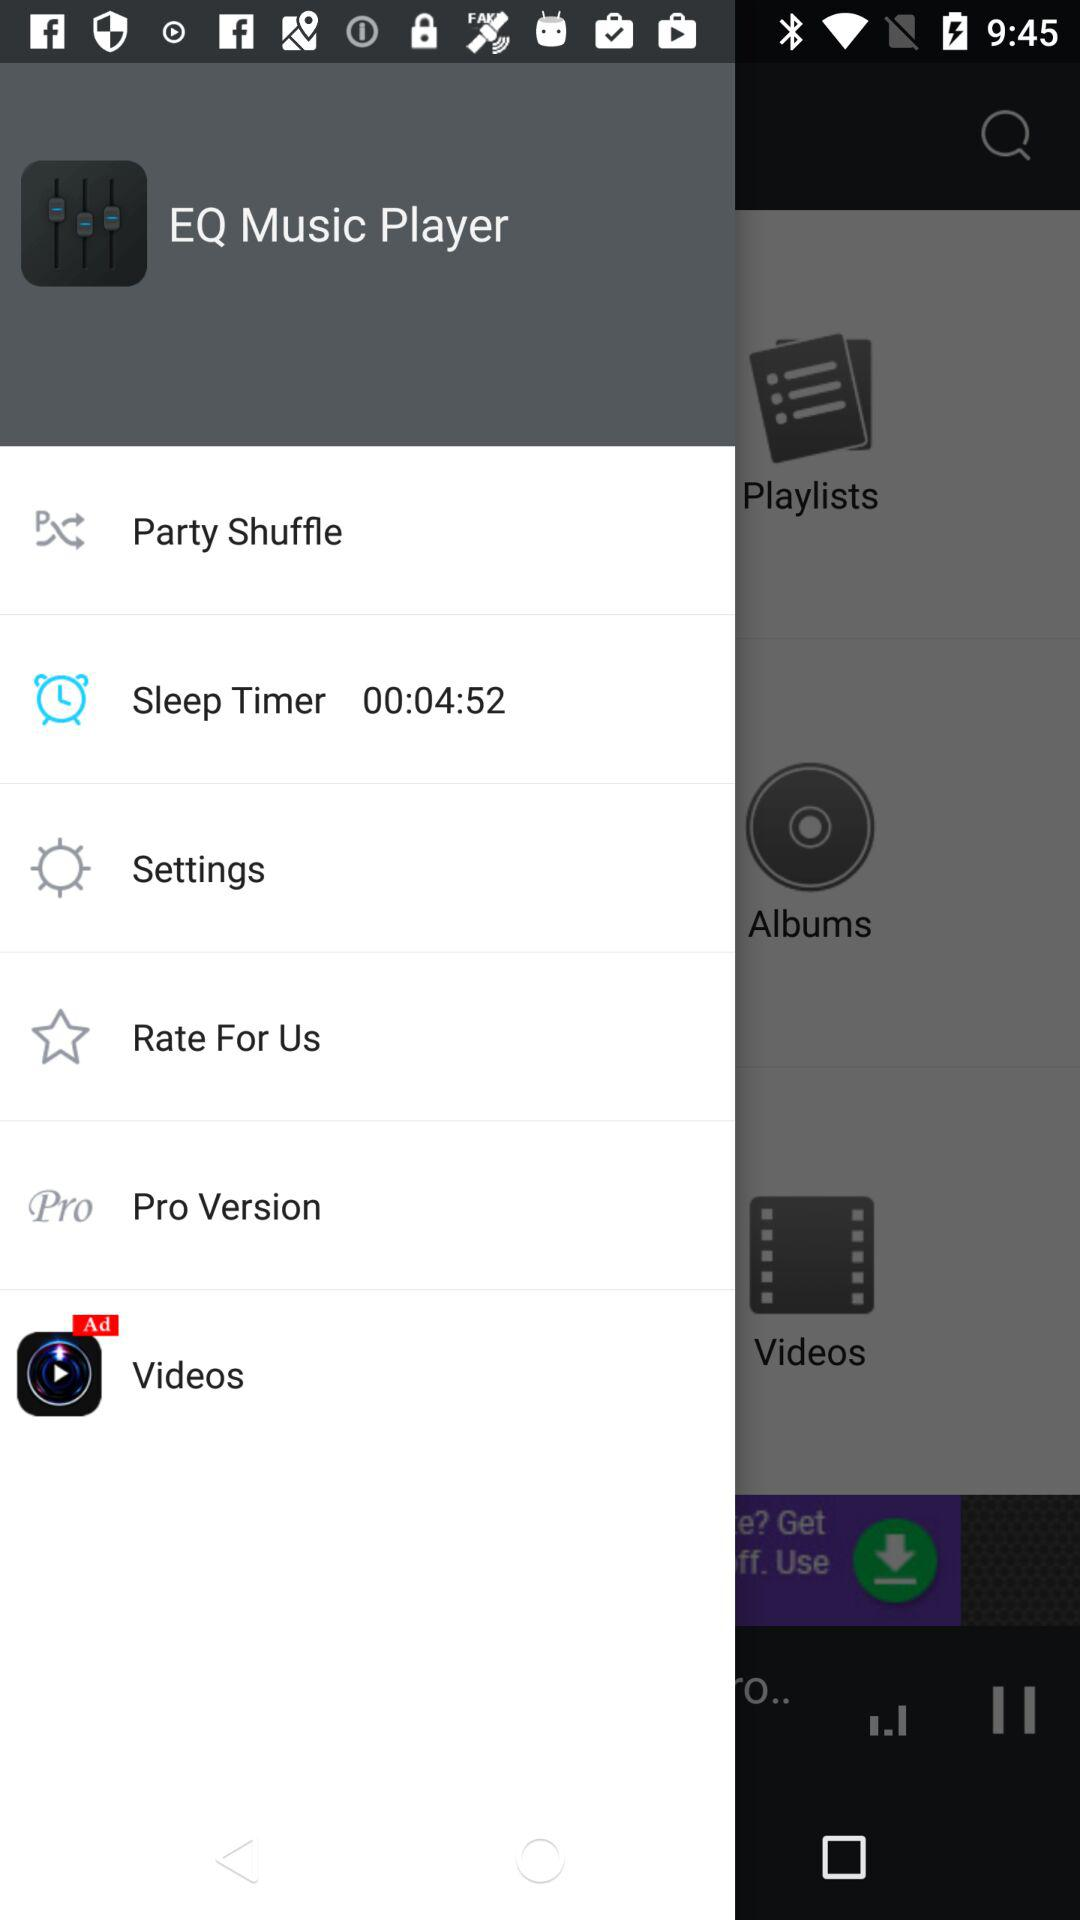What is the name of the application? The name of the application is "EQ Music Player". 